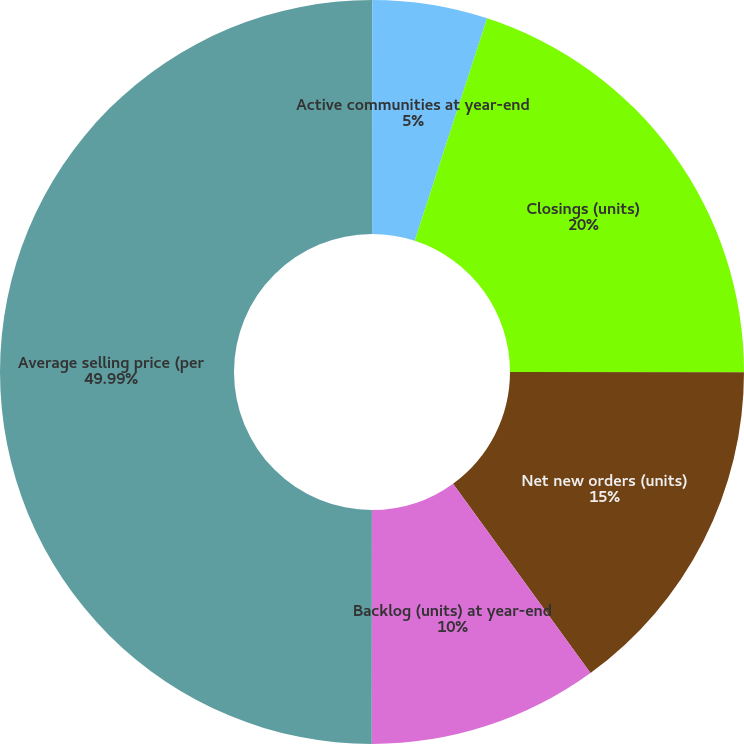Convert chart to OTSL. <chart><loc_0><loc_0><loc_500><loc_500><pie_chart><fcel>Markets at year-end<fcel>Active communities at year-end<fcel>Closings (units)<fcel>Net new orders (units)<fcel>Backlog (units) at year-end<fcel>Average selling price (per<nl><fcel>0.01%<fcel>5.0%<fcel>20.0%<fcel>15.0%<fcel>10.0%<fcel>49.99%<nl></chart> 